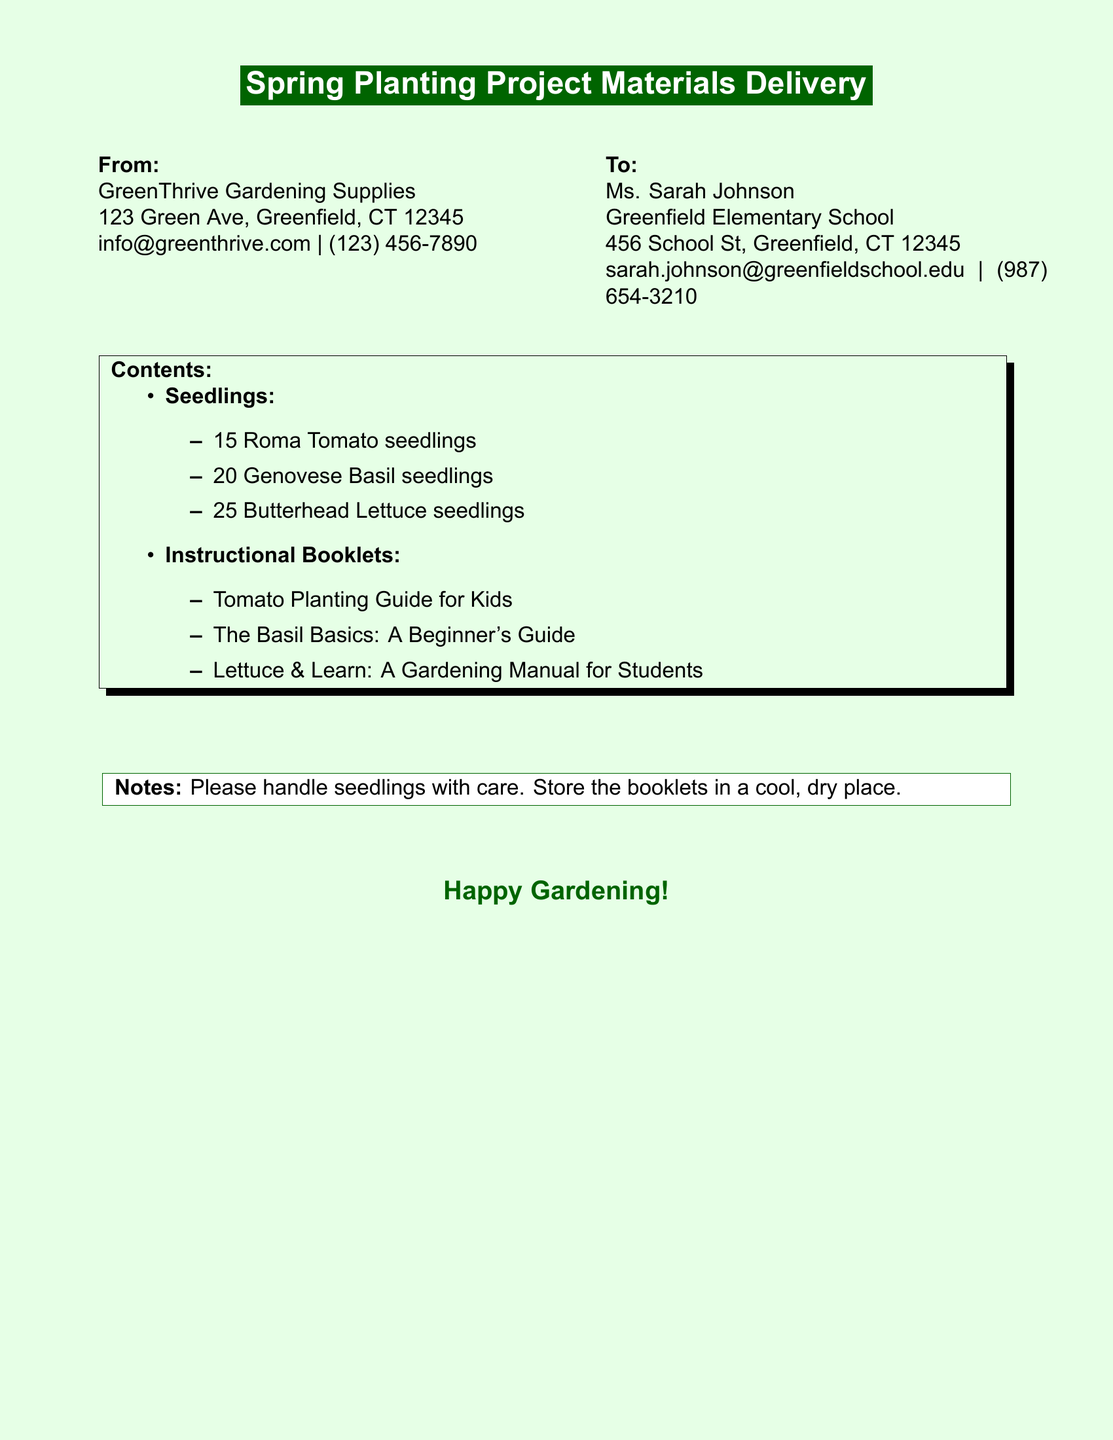What is the name of the company sending the materials? The sender's name is listed in the "From" section of the document as GreenThrive Gardening Supplies.
Answer: GreenThrive Gardening Supplies How many Roma Tomato seedlings are included? The number of Roma Tomato seedlings is specified in the "Seedlings" list in the document.
Answer: 15 Who is the recipient of the shipping label? The recipient's name appears in the "To" section of the document as Ms. Sarah Johnson.
Answer: Ms. Sarah Johnson What type of gardening manual is included for basil? The specific manual for basil is listed under "Instructional Booklets" in the document.
Answer: The Basil Basics: A Beginner's Guide What should be done with the seedlings? The "Notes" section contains information about handling, which provides guidance on the seedlings.
Answer: Please handle seedlings with care How many Butterhead Lettuce seedlings are included? The document specifies the quantity of Butterhead Lettuce seedlings in the "Seedlings" list.
Answer: 25 Which city is Greenfield Elementary School located in? The recipient's address in the "To" section includes the city of the school.
Answer: Greenfield What is the color of the shadow box surrounding the contents section? The color of the shadow box is described in the visual elements of the document, specifically the section titled "Contents."
Answer: Dark green 